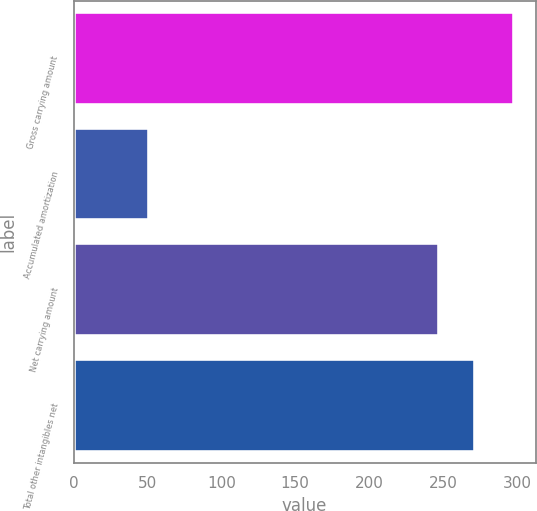<chart> <loc_0><loc_0><loc_500><loc_500><bar_chart><fcel>Gross carrying amount<fcel>Accumulated amortization<fcel>Net carrying amount<fcel>Total other intangibles net<nl><fcel>297.9<fcel>50.9<fcel>247<fcel>271.7<nl></chart> 